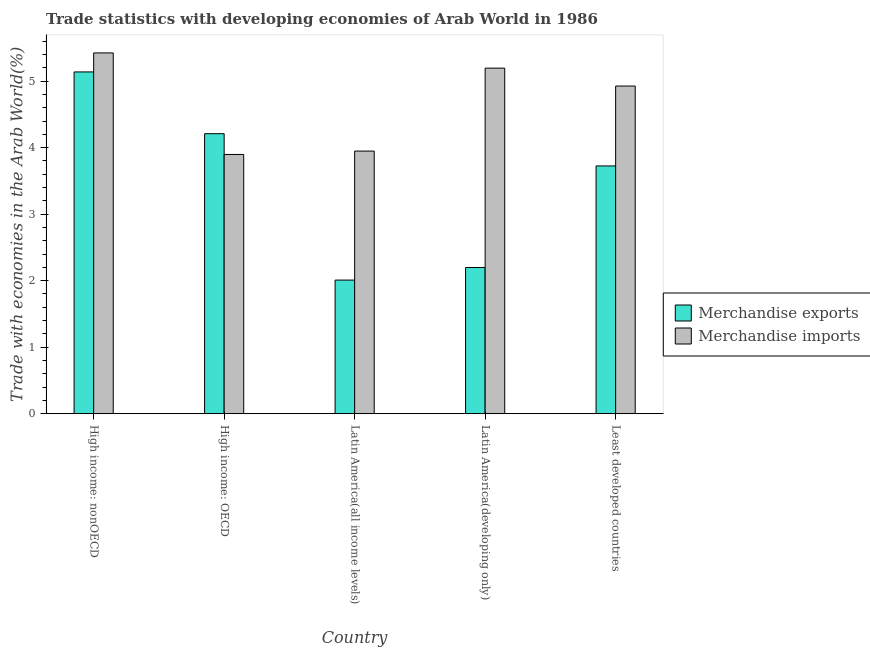How many different coloured bars are there?
Your answer should be very brief. 2. How many groups of bars are there?
Ensure brevity in your answer.  5. Are the number of bars per tick equal to the number of legend labels?
Offer a very short reply. Yes. How many bars are there on the 5th tick from the left?
Give a very brief answer. 2. How many bars are there on the 1st tick from the right?
Give a very brief answer. 2. What is the label of the 1st group of bars from the left?
Make the answer very short. High income: nonOECD. In how many cases, is the number of bars for a given country not equal to the number of legend labels?
Your response must be concise. 0. What is the merchandise imports in High income: OECD?
Give a very brief answer. 3.9. Across all countries, what is the maximum merchandise exports?
Make the answer very short. 5.14. Across all countries, what is the minimum merchandise exports?
Ensure brevity in your answer.  2.01. In which country was the merchandise imports maximum?
Your answer should be very brief. High income: nonOECD. In which country was the merchandise exports minimum?
Keep it short and to the point. Latin America(all income levels). What is the total merchandise imports in the graph?
Give a very brief answer. 23.39. What is the difference between the merchandise imports in High income: OECD and that in Latin America(developing only)?
Your answer should be very brief. -1.3. What is the difference between the merchandise imports in Latin America(all income levels) and the merchandise exports in High income: OECD?
Ensure brevity in your answer.  -0.26. What is the average merchandise exports per country?
Your response must be concise. 3.46. What is the difference between the merchandise exports and merchandise imports in Latin America(all income levels)?
Your response must be concise. -1.94. In how many countries, is the merchandise imports greater than 1.6 %?
Offer a terse response. 5. What is the ratio of the merchandise imports in High income: nonOECD to that in Latin America(all income levels)?
Make the answer very short. 1.37. Is the merchandise exports in High income: nonOECD less than that in Latin America(all income levels)?
Make the answer very short. No. Is the difference between the merchandise exports in Latin America(all income levels) and Latin America(developing only) greater than the difference between the merchandise imports in Latin America(all income levels) and Latin America(developing only)?
Provide a succinct answer. Yes. What is the difference between the highest and the second highest merchandise exports?
Provide a succinct answer. 0.93. What is the difference between the highest and the lowest merchandise exports?
Offer a terse response. 3.13. What does the 2nd bar from the right in High income: OECD represents?
Your answer should be very brief. Merchandise exports. How many bars are there?
Provide a succinct answer. 10. How many countries are there in the graph?
Your answer should be compact. 5. What is the difference between two consecutive major ticks on the Y-axis?
Provide a short and direct response. 1. Are the values on the major ticks of Y-axis written in scientific E-notation?
Your response must be concise. No. Does the graph contain grids?
Keep it short and to the point. No. How are the legend labels stacked?
Offer a terse response. Vertical. What is the title of the graph?
Keep it short and to the point. Trade statistics with developing economies of Arab World in 1986. What is the label or title of the Y-axis?
Your answer should be compact. Trade with economies in the Arab World(%). What is the Trade with economies in the Arab World(%) in Merchandise exports in High income: nonOECD?
Provide a succinct answer. 5.14. What is the Trade with economies in the Arab World(%) of Merchandise imports in High income: nonOECD?
Offer a terse response. 5.42. What is the Trade with economies in the Arab World(%) of Merchandise exports in High income: OECD?
Your response must be concise. 4.21. What is the Trade with economies in the Arab World(%) in Merchandise imports in High income: OECD?
Keep it short and to the point. 3.9. What is the Trade with economies in the Arab World(%) in Merchandise exports in Latin America(all income levels)?
Keep it short and to the point. 2.01. What is the Trade with economies in the Arab World(%) in Merchandise imports in Latin America(all income levels)?
Make the answer very short. 3.95. What is the Trade with economies in the Arab World(%) of Merchandise exports in Latin America(developing only)?
Your answer should be compact. 2.2. What is the Trade with economies in the Arab World(%) in Merchandise imports in Latin America(developing only)?
Make the answer very short. 5.2. What is the Trade with economies in the Arab World(%) in Merchandise exports in Least developed countries?
Ensure brevity in your answer.  3.72. What is the Trade with economies in the Arab World(%) of Merchandise imports in Least developed countries?
Make the answer very short. 4.93. Across all countries, what is the maximum Trade with economies in the Arab World(%) of Merchandise exports?
Provide a succinct answer. 5.14. Across all countries, what is the maximum Trade with economies in the Arab World(%) of Merchandise imports?
Your answer should be compact. 5.42. Across all countries, what is the minimum Trade with economies in the Arab World(%) of Merchandise exports?
Ensure brevity in your answer.  2.01. Across all countries, what is the minimum Trade with economies in the Arab World(%) in Merchandise imports?
Offer a very short reply. 3.9. What is the total Trade with economies in the Arab World(%) in Merchandise exports in the graph?
Offer a very short reply. 17.28. What is the total Trade with economies in the Arab World(%) in Merchandise imports in the graph?
Provide a succinct answer. 23.39. What is the difference between the Trade with economies in the Arab World(%) of Merchandise exports in High income: nonOECD and that in High income: OECD?
Your answer should be very brief. 0.93. What is the difference between the Trade with economies in the Arab World(%) of Merchandise imports in High income: nonOECD and that in High income: OECD?
Provide a short and direct response. 1.53. What is the difference between the Trade with economies in the Arab World(%) of Merchandise exports in High income: nonOECD and that in Latin America(all income levels)?
Offer a terse response. 3.13. What is the difference between the Trade with economies in the Arab World(%) of Merchandise imports in High income: nonOECD and that in Latin America(all income levels)?
Your answer should be compact. 1.48. What is the difference between the Trade with economies in the Arab World(%) of Merchandise exports in High income: nonOECD and that in Latin America(developing only)?
Your response must be concise. 2.94. What is the difference between the Trade with economies in the Arab World(%) in Merchandise imports in High income: nonOECD and that in Latin America(developing only)?
Give a very brief answer. 0.23. What is the difference between the Trade with economies in the Arab World(%) in Merchandise exports in High income: nonOECD and that in Least developed countries?
Make the answer very short. 1.41. What is the difference between the Trade with economies in the Arab World(%) in Merchandise imports in High income: nonOECD and that in Least developed countries?
Offer a very short reply. 0.5. What is the difference between the Trade with economies in the Arab World(%) in Merchandise exports in High income: OECD and that in Latin America(all income levels)?
Your response must be concise. 2.2. What is the difference between the Trade with economies in the Arab World(%) of Merchandise imports in High income: OECD and that in Latin America(all income levels)?
Make the answer very short. -0.05. What is the difference between the Trade with economies in the Arab World(%) of Merchandise exports in High income: OECD and that in Latin America(developing only)?
Your answer should be compact. 2.01. What is the difference between the Trade with economies in the Arab World(%) of Merchandise imports in High income: OECD and that in Latin America(developing only)?
Your answer should be compact. -1.3. What is the difference between the Trade with economies in the Arab World(%) of Merchandise exports in High income: OECD and that in Least developed countries?
Your answer should be very brief. 0.48. What is the difference between the Trade with economies in the Arab World(%) of Merchandise imports in High income: OECD and that in Least developed countries?
Ensure brevity in your answer.  -1.03. What is the difference between the Trade with economies in the Arab World(%) in Merchandise exports in Latin America(all income levels) and that in Latin America(developing only)?
Give a very brief answer. -0.19. What is the difference between the Trade with economies in the Arab World(%) in Merchandise imports in Latin America(all income levels) and that in Latin America(developing only)?
Your response must be concise. -1.25. What is the difference between the Trade with economies in the Arab World(%) of Merchandise exports in Latin America(all income levels) and that in Least developed countries?
Keep it short and to the point. -1.72. What is the difference between the Trade with economies in the Arab World(%) in Merchandise imports in Latin America(all income levels) and that in Least developed countries?
Your response must be concise. -0.98. What is the difference between the Trade with economies in the Arab World(%) in Merchandise exports in Latin America(developing only) and that in Least developed countries?
Provide a short and direct response. -1.53. What is the difference between the Trade with economies in the Arab World(%) in Merchandise imports in Latin America(developing only) and that in Least developed countries?
Offer a terse response. 0.27. What is the difference between the Trade with economies in the Arab World(%) of Merchandise exports in High income: nonOECD and the Trade with economies in the Arab World(%) of Merchandise imports in High income: OECD?
Provide a short and direct response. 1.24. What is the difference between the Trade with economies in the Arab World(%) of Merchandise exports in High income: nonOECD and the Trade with economies in the Arab World(%) of Merchandise imports in Latin America(all income levels)?
Your answer should be very brief. 1.19. What is the difference between the Trade with economies in the Arab World(%) in Merchandise exports in High income: nonOECD and the Trade with economies in the Arab World(%) in Merchandise imports in Latin America(developing only)?
Give a very brief answer. -0.06. What is the difference between the Trade with economies in the Arab World(%) of Merchandise exports in High income: nonOECD and the Trade with economies in the Arab World(%) of Merchandise imports in Least developed countries?
Give a very brief answer. 0.21. What is the difference between the Trade with economies in the Arab World(%) in Merchandise exports in High income: OECD and the Trade with economies in the Arab World(%) in Merchandise imports in Latin America(all income levels)?
Ensure brevity in your answer.  0.26. What is the difference between the Trade with economies in the Arab World(%) in Merchandise exports in High income: OECD and the Trade with economies in the Arab World(%) in Merchandise imports in Latin America(developing only)?
Offer a very short reply. -0.99. What is the difference between the Trade with economies in the Arab World(%) in Merchandise exports in High income: OECD and the Trade with economies in the Arab World(%) in Merchandise imports in Least developed countries?
Provide a short and direct response. -0.72. What is the difference between the Trade with economies in the Arab World(%) in Merchandise exports in Latin America(all income levels) and the Trade with economies in the Arab World(%) in Merchandise imports in Latin America(developing only)?
Provide a succinct answer. -3.19. What is the difference between the Trade with economies in the Arab World(%) in Merchandise exports in Latin America(all income levels) and the Trade with economies in the Arab World(%) in Merchandise imports in Least developed countries?
Provide a succinct answer. -2.92. What is the difference between the Trade with economies in the Arab World(%) of Merchandise exports in Latin America(developing only) and the Trade with economies in the Arab World(%) of Merchandise imports in Least developed countries?
Provide a short and direct response. -2.73. What is the average Trade with economies in the Arab World(%) of Merchandise exports per country?
Make the answer very short. 3.46. What is the average Trade with economies in the Arab World(%) in Merchandise imports per country?
Make the answer very short. 4.68. What is the difference between the Trade with economies in the Arab World(%) in Merchandise exports and Trade with economies in the Arab World(%) in Merchandise imports in High income: nonOECD?
Give a very brief answer. -0.29. What is the difference between the Trade with economies in the Arab World(%) of Merchandise exports and Trade with economies in the Arab World(%) of Merchandise imports in High income: OECD?
Offer a very short reply. 0.31. What is the difference between the Trade with economies in the Arab World(%) of Merchandise exports and Trade with economies in the Arab World(%) of Merchandise imports in Latin America(all income levels)?
Your answer should be very brief. -1.94. What is the difference between the Trade with economies in the Arab World(%) of Merchandise exports and Trade with economies in the Arab World(%) of Merchandise imports in Latin America(developing only)?
Provide a short and direct response. -3. What is the difference between the Trade with economies in the Arab World(%) of Merchandise exports and Trade with economies in the Arab World(%) of Merchandise imports in Least developed countries?
Provide a succinct answer. -1.2. What is the ratio of the Trade with economies in the Arab World(%) of Merchandise exports in High income: nonOECD to that in High income: OECD?
Offer a terse response. 1.22. What is the ratio of the Trade with economies in the Arab World(%) in Merchandise imports in High income: nonOECD to that in High income: OECD?
Your answer should be compact. 1.39. What is the ratio of the Trade with economies in the Arab World(%) in Merchandise exports in High income: nonOECD to that in Latin America(all income levels)?
Provide a succinct answer. 2.56. What is the ratio of the Trade with economies in the Arab World(%) in Merchandise imports in High income: nonOECD to that in Latin America(all income levels)?
Your response must be concise. 1.37. What is the ratio of the Trade with economies in the Arab World(%) in Merchandise exports in High income: nonOECD to that in Latin America(developing only)?
Your answer should be compact. 2.34. What is the ratio of the Trade with economies in the Arab World(%) in Merchandise imports in High income: nonOECD to that in Latin America(developing only)?
Keep it short and to the point. 1.04. What is the ratio of the Trade with economies in the Arab World(%) in Merchandise exports in High income: nonOECD to that in Least developed countries?
Make the answer very short. 1.38. What is the ratio of the Trade with economies in the Arab World(%) in Merchandise imports in High income: nonOECD to that in Least developed countries?
Keep it short and to the point. 1.1. What is the ratio of the Trade with economies in the Arab World(%) of Merchandise exports in High income: OECD to that in Latin America(all income levels)?
Keep it short and to the point. 2.1. What is the ratio of the Trade with economies in the Arab World(%) of Merchandise imports in High income: OECD to that in Latin America(all income levels)?
Offer a very short reply. 0.99. What is the ratio of the Trade with economies in the Arab World(%) of Merchandise exports in High income: OECD to that in Latin America(developing only)?
Your answer should be very brief. 1.91. What is the ratio of the Trade with economies in the Arab World(%) of Merchandise imports in High income: OECD to that in Latin America(developing only)?
Your response must be concise. 0.75. What is the ratio of the Trade with economies in the Arab World(%) in Merchandise exports in High income: OECD to that in Least developed countries?
Your answer should be compact. 1.13. What is the ratio of the Trade with economies in the Arab World(%) in Merchandise imports in High income: OECD to that in Least developed countries?
Your answer should be compact. 0.79. What is the ratio of the Trade with economies in the Arab World(%) in Merchandise exports in Latin America(all income levels) to that in Latin America(developing only)?
Provide a succinct answer. 0.91. What is the ratio of the Trade with economies in the Arab World(%) of Merchandise imports in Latin America(all income levels) to that in Latin America(developing only)?
Give a very brief answer. 0.76. What is the ratio of the Trade with economies in the Arab World(%) in Merchandise exports in Latin America(all income levels) to that in Least developed countries?
Offer a terse response. 0.54. What is the ratio of the Trade with economies in the Arab World(%) of Merchandise imports in Latin America(all income levels) to that in Least developed countries?
Offer a terse response. 0.8. What is the ratio of the Trade with economies in the Arab World(%) in Merchandise exports in Latin America(developing only) to that in Least developed countries?
Give a very brief answer. 0.59. What is the ratio of the Trade with economies in the Arab World(%) in Merchandise imports in Latin America(developing only) to that in Least developed countries?
Your answer should be compact. 1.05. What is the difference between the highest and the second highest Trade with economies in the Arab World(%) of Merchandise exports?
Offer a very short reply. 0.93. What is the difference between the highest and the second highest Trade with economies in the Arab World(%) in Merchandise imports?
Ensure brevity in your answer.  0.23. What is the difference between the highest and the lowest Trade with economies in the Arab World(%) of Merchandise exports?
Ensure brevity in your answer.  3.13. What is the difference between the highest and the lowest Trade with economies in the Arab World(%) of Merchandise imports?
Your answer should be compact. 1.53. 